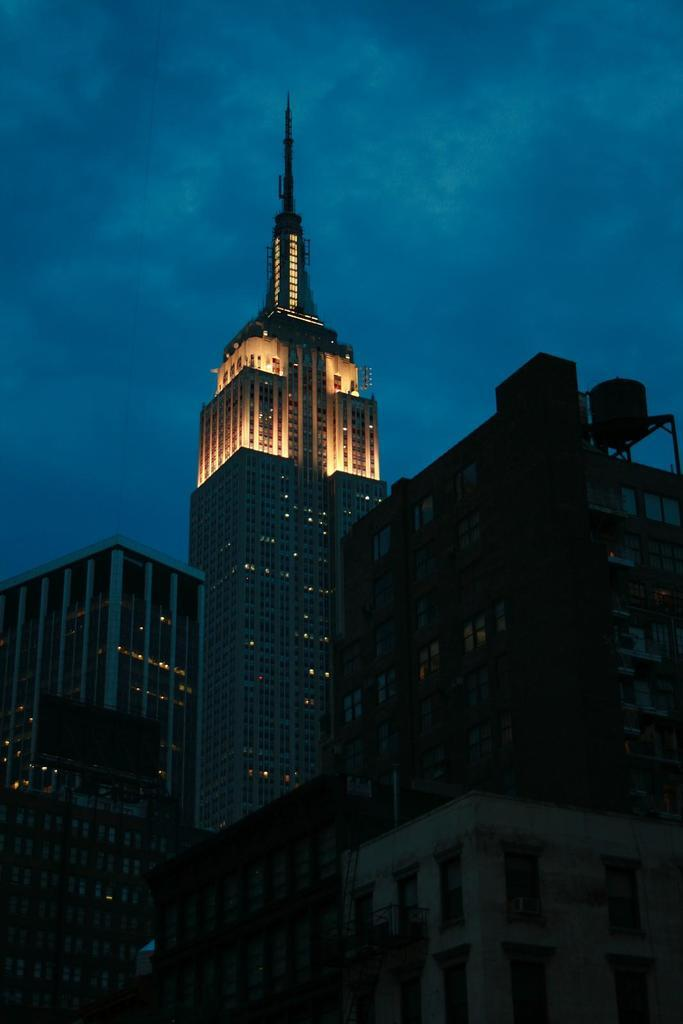What time of day was the image taken? The image was taken during night time. What structures can be seen in the image? There are buildings in the image. What can be seen illuminating the scene in the image? There are lights visible in the image. What is visible in the background of the image? The sky is visible in the background of the image. What type of wing can be seen in the image? There is no wing present in the image. Can you locate a map in the image? There is no map visible in the image. 